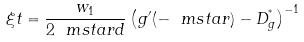<formula> <loc_0><loc_0><loc_500><loc_500>\xi t = \frac { w _ { 1 } } { 2 \ m s t a r d } \left ( g ^ { \prime } ( - \ m s t a r ) - D ^ { ^ { * } } _ { g } \right ) ^ { - 1 }</formula> 